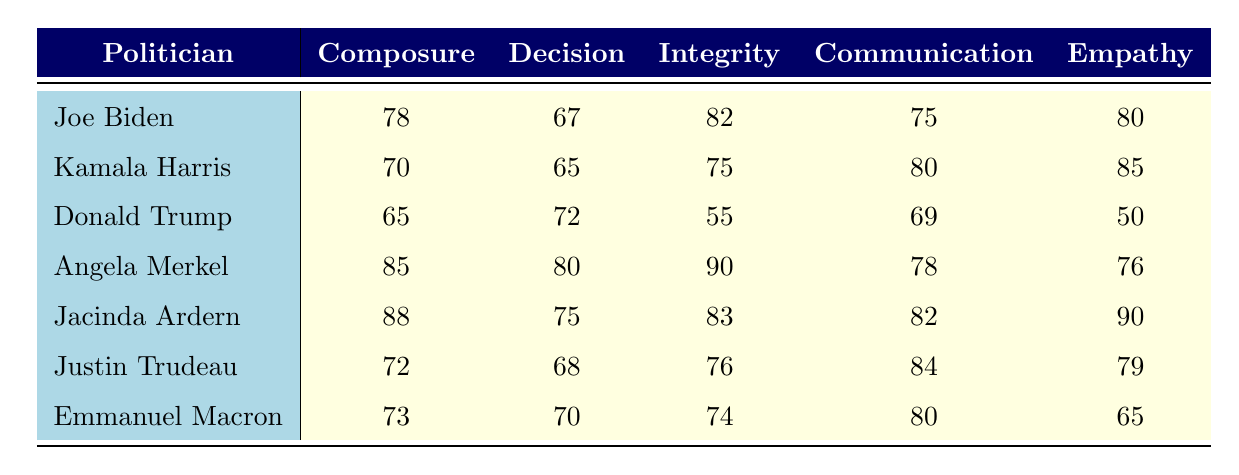What is the highest score for Composure Under Pressure? By examining the Composure Under Pressure values in the table, I find that Jacinda Ardern has the highest score of 88.
Answer: 88 Which politician has the lowest Integrity score? Looking at the Integrity scores, Donald Trump has the lowest score at 55.
Answer: 55 What is the average score for Communication Skills across all politicians? The Communication Skills scores are 75, 80, 69, 78, 82, 84, and 80. The sum is 528 and there are 7 scores, so 528/7 = 75.43.
Answer: 75.43 True or False: Joe Biden has a higher score in Empathy than Donald Trump. Joe Biden's score in Empathy is 80, while Donald Trump's is 50. Since 80 is greater than 50, the statement is true.
Answer: True Which politician has the highest score for Decision Making? The Decision Making scores are 67, 65, 72, 80, 75, 68, and 70. Angela Merkel has the highest score at 80.
Answer: 80 What is the difference in Composure Under Pressure between Jacinda Ardern and Kamala Harris? Jacinda Ardern's score is 88, and Kamala Harris' score is 70. The difference is 88 - 70 = 18.
Answer: 18 What is the average score of Empathy for all politicians except Donald Trump? The Empathy scores are 80, 85, 50, 76, 90, 79, and 65. Excluding Trump, the scores are 80, 85, 76, 90, and 79. The sum is 410 and there are 5 scores, giving an average of 410/5 = 82.
Answer: 82 How many politicians scored above 75 for Integrity? The Integrity scores are 82, 75, 55, 90, 83, 76, and 74. The politicians with scores above 75 are Joe Biden, Angela Merkel, Jacinda Ardern, and Justin Trudeau, totaling 4 politicians.
Answer: 4 Is there a politician who scores the same in Composure Under Pressure and Communication Skills? By checking the scores, I find that none of the politicians have the same score in both categories—there are no matches.
Answer: No Which two politicians have the closest scores in Empathy? The Empathy scores are 80, 85, 50, 76, 90, 79, and 65. Kamala Harris (85) and Justin Trudeau (79) have the closest scores, with a difference of 6.
Answer: 6 